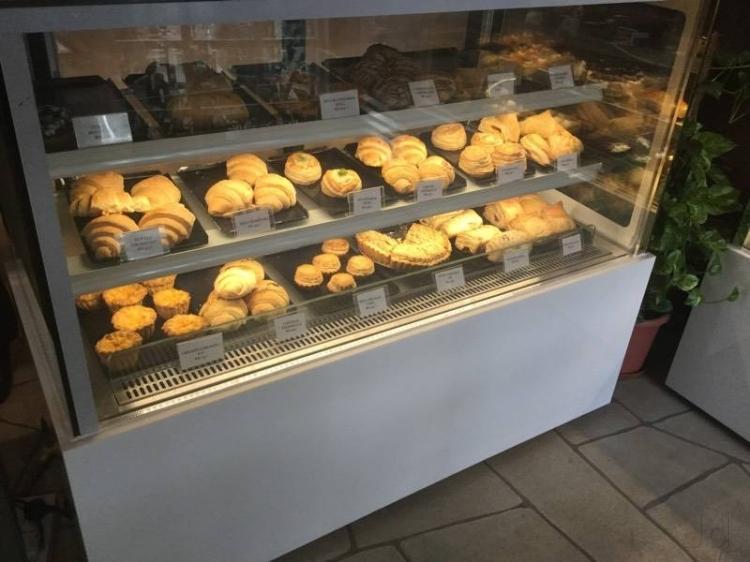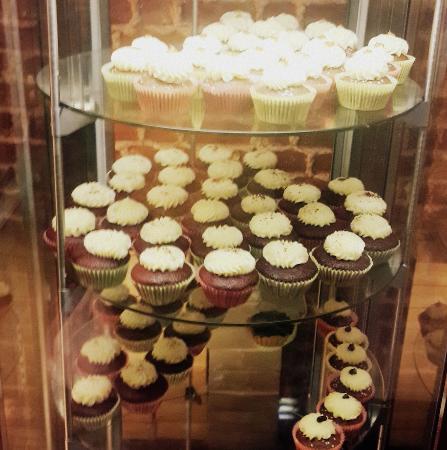The first image is the image on the left, the second image is the image on the right. For the images displayed, is the sentence "The right image shows round frosted cake-type desserts displayed on round glass shelves in a tall glass-fronted case." factually correct? Answer yes or no. Yes. The first image is the image on the left, the second image is the image on the right. Assess this claim about the two images: "The right image contains at least one table with napkins on it.". Correct or not? Answer yes or no. No. 